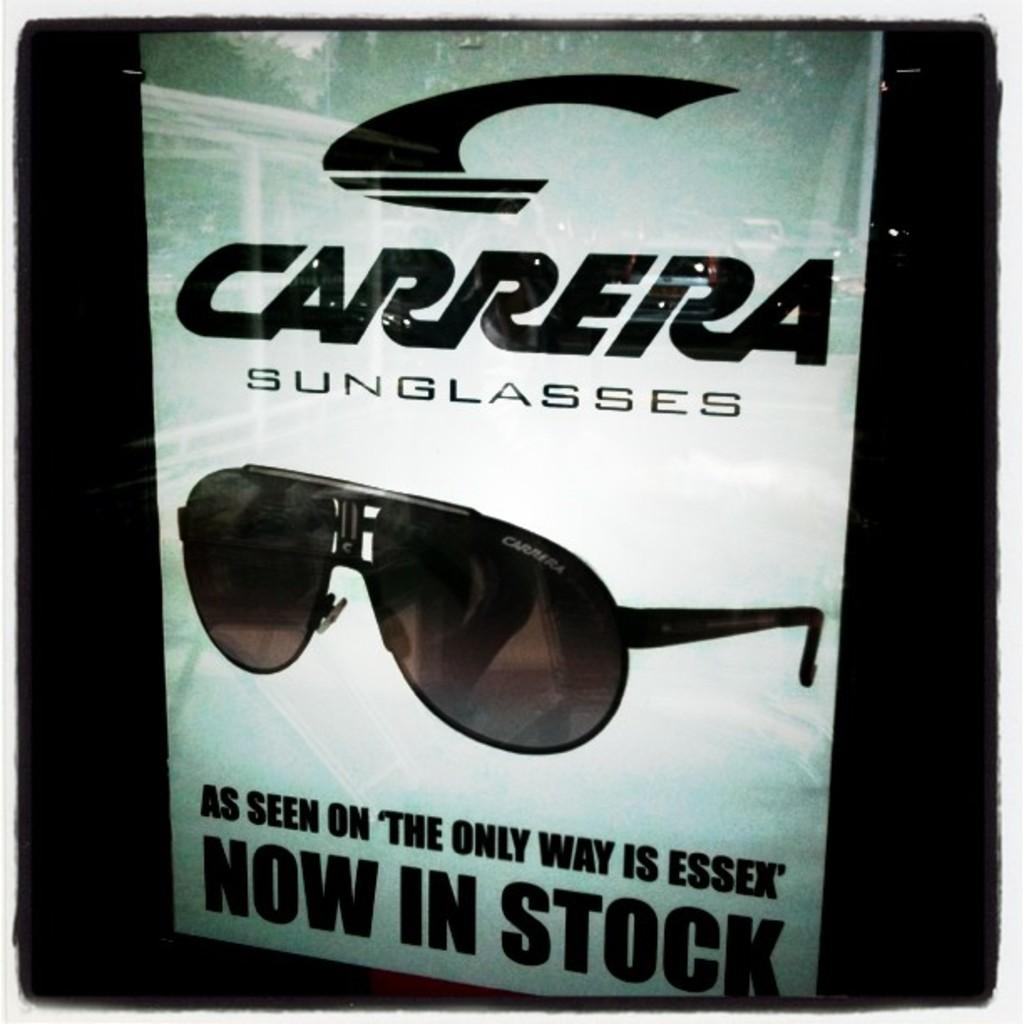What is the main object in the image? There is a banner in the image. What can be seen on the banner? The banner has text on it and depicts goggles. What is the color of the background in the image? The background of the image is dark. What type of patch can be seen on the banner in the image? There is no patch depicted on the banner in the image. What kind of drink is being advertised on the banner? The banner does not advertise any drink; it features text and an image of goggles. 